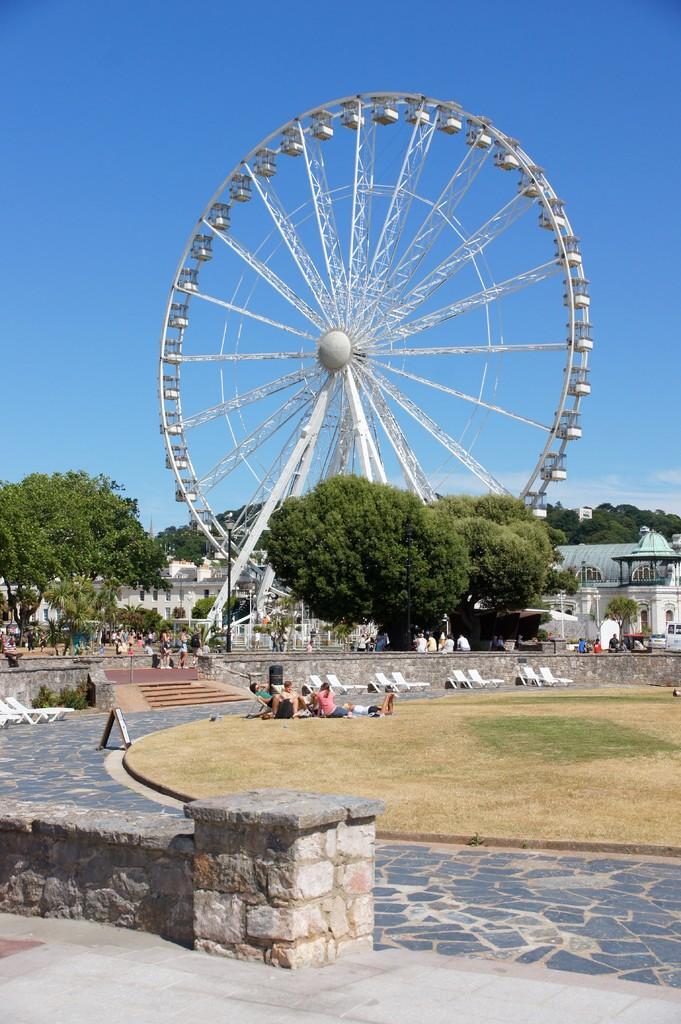Please provide a concise description of this image. At the bottom of the image we can see wall. In the middle of the image we can see some trees, poles, benches, plants and few people are sitting and standing. At the top of the image we can see a joint wheel. Behind the joint wheel we can see the sky. 